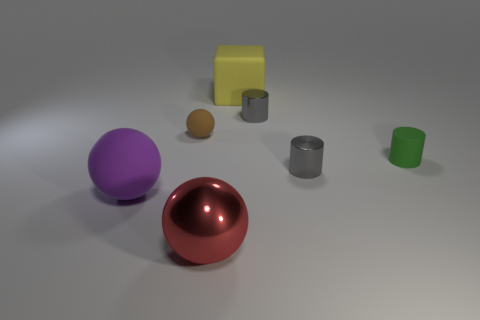Is the number of gray metallic cylinders behind the large yellow thing greater than the number of green matte things that are behind the brown thing?
Offer a terse response. No. Do the big thing that is left of the red ball and the small gray cylinder behind the tiny green rubber object have the same material?
Offer a terse response. No. There is a green rubber thing that is the same size as the brown thing; what shape is it?
Keep it short and to the point. Cylinder. Are there any other tiny things that have the same shape as the red shiny object?
Offer a very short reply. Yes. Do the tiny object in front of the tiny green rubber cylinder and the rubber sphere in front of the small green object have the same color?
Offer a terse response. No. Are there any big yellow blocks left of the yellow thing?
Give a very brief answer. No. What is the object that is both on the left side of the red ball and in front of the tiny rubber ball made of?
Make the answer very short. Rubber. Is the large object that is behind the brown ball made of the same material as the red sphere?
Make the answer very short. No. What is the material of the yellow block?
Provide a short and direct response. Rubber. There is a purple ball behind the red metal sphere; what is its size?
Make the answer very short. Large. 